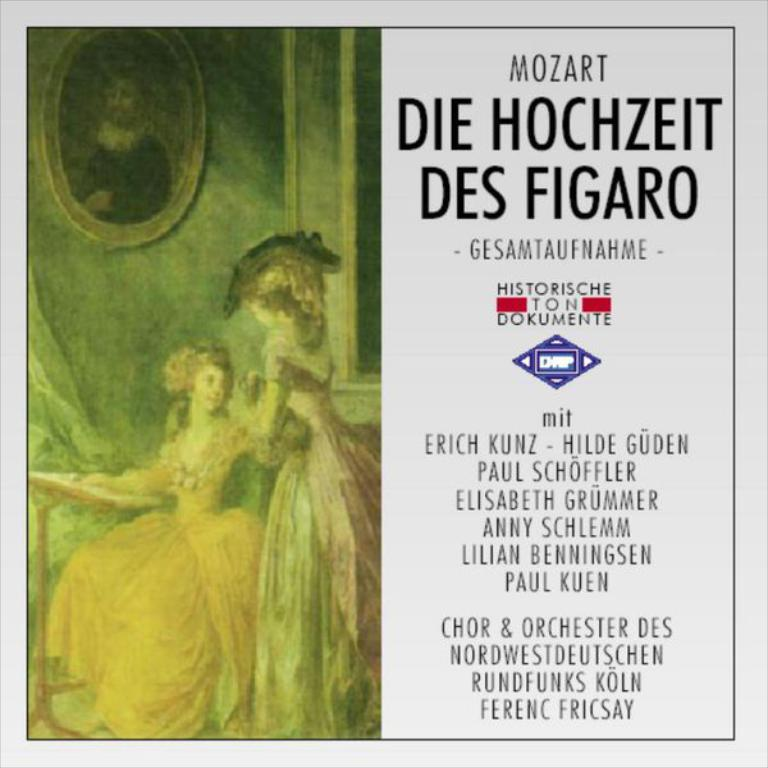Provide a one-sentence caption for the provided image. A brochure for an orchestra featuring Erich Kunz, Hilde Guden and some other people. 